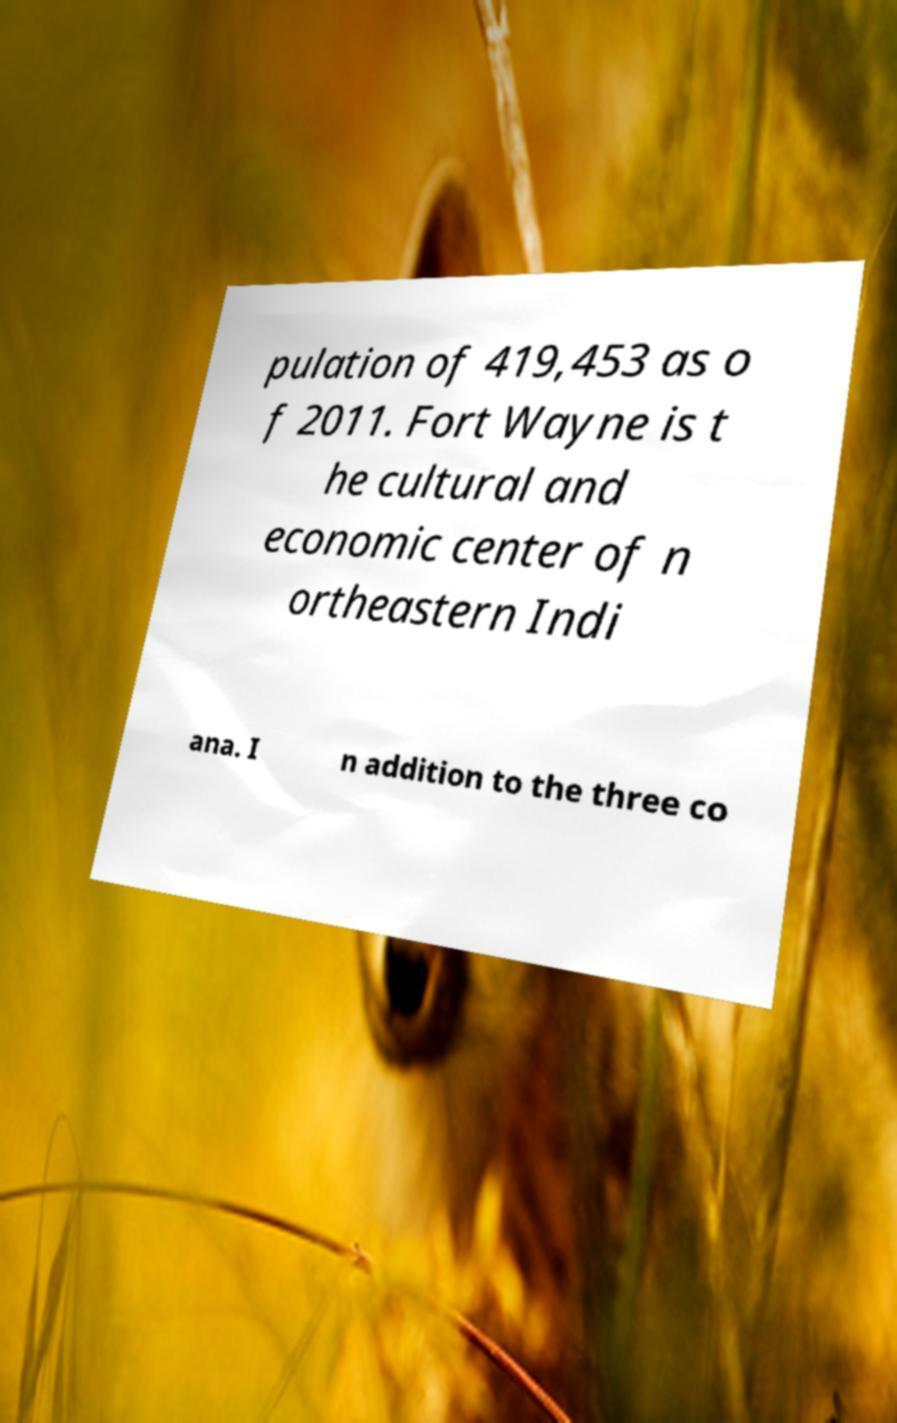For documentation purposes, I need the text within this image transcribed. Could you provide that? pulation of 419,453 as o f 2011. Fort Wayne is t he cultural and economic center of n ortheastern Indi ana. I n addition to the three co 